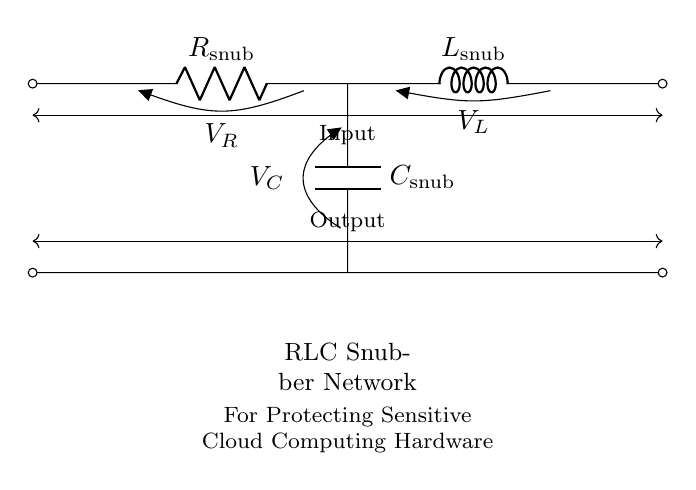What are the components in the RLC snubber network? The components are a resistor, inductor, and capacitor. These are visually represented in the circuit with labels R, L, and C.
Answer: resistor, inductor, capacitor What is the function of the RLC snubber network? The purpose of the RLC snubber network is to protect sensitive components from voltage spikes and transients, ensuring stable operation in cloud computing hardware.
Answer: protect sensitive components What is the value of the resistor in the circuit? The resistor is labeled as Rsnub; however, its value is not provided in the diagram. Circuit diagrams typically denote component types rather than numeric values.
Answer: Rsnub Which component is connected directly to the output? The output connects directly to the capacitor. In the circuit, Csnub is at the bottom in line, ensuring it's the last component before the output.
Answer: capacitor What voltage drop occurs across the inductor? The voltage across the inductor is denoted as VL. The circuit indicates it exists but doesn't provide a specific numeric value in the diagram.
Answer: VL How does the RLC snubber network affect transient response? The RLC configuration helps dampen voltage spikes and transients, providing a smoother response. Therefore, it enhances the reliability of cloud computing hardware by preventing overvoltage conditions.
Answer: dampens transients What is the orientation of the flow of current in this circuit? Current flows from the input to the output through the resistor, inductor, and capacitor in that specific order, defining a clear path in the circuit layout.
Answer: from input to output 